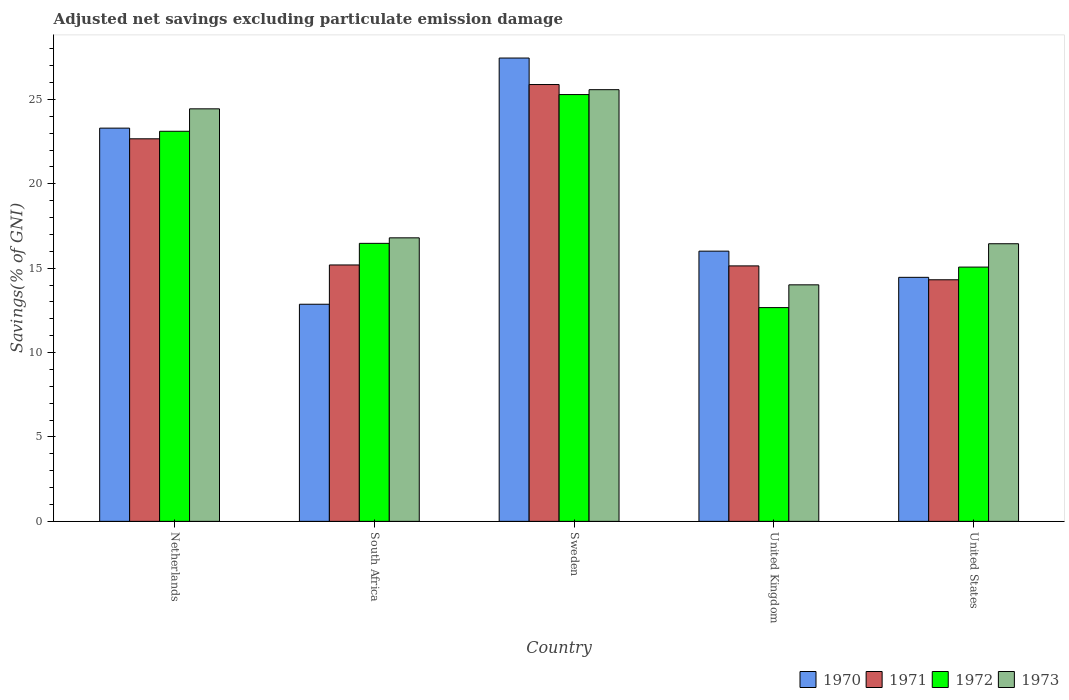How many different coloured bars are there?
Give a very brief answer. 4. Are the number of bars per tick equal to the number of legend labels?
Your response must be concise. Yes. How many bars are there on the 2nd tick from the left?
Offer a very short reply. 4. How many bars are there on the 3rd tick from the right?
Your response must be concise. 4. What is the label of the 2nd group of bars from the left?
Offer a terse response. South Africa. What is the adjusted net savings in 1970 in Sweden?
Give a very brief answer. 27.45. Across all countries, what is the maximum adjusted net savings in 1970?
Offer a very short reply. 27.45. Across all countries, what is the minimum adjusted net savings in 1971?
Your answer should be very brief. 14.31. What is the total adjusted net savings in 1972 in the graph?
Ensure brevity in your answer.  92.59. What is the difference between the adjusted net savings in 1973 in United Kingdom and that in United States?
Offer a terse response. -2.43. What is the difference between the adjusted net savings in 1972 in Sweden and the adjusted net savings in 1970 in South Africa?
Your answer should be very brief. 12.42. What is the average adjusted net savings in 1970 per country?
Your answer should be compact. 18.81. What is the difference between the adjusted net savings of/in 1970 and adjusted net savings of/in 1973 in United Kingdom?
Provide a succinct answer. 2. In how many countries, is the adjusted net savings in 1970 greater than 15 %?
Offer a very short reply. 3. What is the ratio of the adjusted net savings in 1970 in South Africa to that in United States?
Your response must be concise. 0.89. Is the difference between the adjusted net savings in 1970 in Netherlands and South Africa greater than the difference between the adjusted net savings in 1973 in Netherlands and South Africa?
Offer a very short reply. Yes. What is the difference between the highest and the second highest adjusted net savings in 1972?
Your answer should be compact. -8.81. What is the difference between the highest and the lowest adjusted net savings in 1973?
Your response must be concise. 11.56. Is the sum of the adjusted net savings in 1973 in South Africa and United Kingdom greater than the maximum adjusted net savings in 1972 across all countries?
Keep it short and to the point. Yes. What does the 3rd bar from the left in South Africa represents?
Give a very brief answer. 1972. Are all the bars in the graph horizontal?
Keep it short and to the point. No. Are the values on the major ticks of Y-axis written in scientific E-notation?
Make the answer very short. No. Does the graph contain any zero values?
Provide a short and direct response. No. What is the title of the graph?
Offer a terse response. Adjusted net savings excluding particulate emission damage. What is the label or title of the X-axis?
Ensure brevity in your answer.  Country. What is the label or title of the Y-axis?
Make the answer very short. Savings(% of GNI). What is the Savings(% of GNI) in 1970 in Netherlands?
Your answer should be compact. 23.3. What is the Savings(% of GNI) in 1971 in Netherlands?
Provide a short and direct response. 22.66. What is the Savings(% of GNI) in 1972 in Netherlands?
Offer a terse response. 23.11. What is the Savings(% of GNI) in 1973 in Netherlands?
Your answer should be compact. 24.44. What is the Savings(% of GNI) of 1970 in South Africa?
Offer a terse response. 12.86. What is the Savings(% of GNI) of 1971 in South Africa?
Offer a very short reply. 15.19. What is the Savings(% of GNI) of 1972 in South Africa?
Provide a short and direct response. 16.47. What is the Savings(% of GNI) of 1973 in South Africa?
Make the answer very short. 16.8. What is the Savings(% of GNI) in 1970 in Sweden?
Offer a very short reply. 27.45. What is the Savings(% of GNI) in 1971 in Sweden?
Your answer should be very brief. 25.88. What is the Savings(% of GNI) in 1972 in Sweden?
Provide a short and direct response. 25.28. What is the Savings(% of GNI) in 1973 in Sweden?
Your response must be concise. 25.57. What is the Savings(% of GNI) in 1970 in United Kingdom?
Ensure brevity in your answer.  16.01. What is the Savings(% of GNI) in 1971 in United Kingdom?
Keep it short and to the point. 15.13. What is the Savings(% of GNI) in 1972 in United Kingdom?
Your answer should be compact. 12.66. What is the Savings(% of GNI) of 1973 in United Kingdom?
Your answer should be very brief. 14.01. What is the Savings(% of GNI) in 1970 in United States?
Your answer should be compact. 14.46. What is the Savings(% of GNI) in 1971 in United States?
Provide a short and direct response. 14.31. What is the Savings(% of GNI) of 1972 in United States?
Make the answer very short. 15.06. What is the Savings(% of GNI) of 1973 in United States?
Make the answer very short. 16.45. Across all countries, what is the maximum Savings(% of GNI) of 1970?
Ensure brevity in your answer.  27.45. Across all countries, what is the maximum Savings(% of GNI) of 1971?
Offer a very short reply. 25.88. Across all countries, what is the maximum Savings(% of GNI) of 1972?
Make the answer very short. 25.28. Across all countries, what is the maximum Savings(% of GNI) of 1973?
Your answer should be compact. 25.57. Across all countries, what is the minimum Savings(% of GNI) of 1970?
Ensure brevity in your answer.  12.86. Across all countries, what is the minimum Savings(% of GNI) in 1971?
Ensure brevity in your answer.  14.31. Across all countries, what is the minimum Savings(% of GNI) in 1972?
Give a very brief answer. 12.66. Across all countries, what is the minimum Savings(% of GNI) of 1973?
Your answer should be very brief. 14.01. What is the total Savings(% of GNI) of 1970 in the graph?
Your answer should be compact. 94.07. What is the total Savings(% of GNI) of 1971 in the graph?
Keep it short and to the point. 93.18. What is the total Savings(% of GNI) in 1972 in the graph?
Provide a short and direct response. 92.59. What is the total Savings(% of GNI) in 1973 in the graph?
Your answer should be compact. 97.27. What is the difference between the Savings(% of GNI) of 1970 in Netherlands and that in South Africa?
Make the answer very short. 10.43. What is the difference between the Savings(% of GNI) in 1971 in Netherlands and that in South Africa?
Provide a succinct answer. 7.47. What is the difference between the Savings(% of GNI) in 1972 in Netherlands and that in South Africa?
Provide a short and direct response. 6.64. What is the difference between the Savings(% of GNI) in 1973 in Netherlands and that in South Africa?
Keep it short and to the point. 7.64. What is the difference between the Savings(% of GNI) in 1970 in Netherlands and that in Sweden?
Keep it short and to the point. -4.15. What is the difference between the Savings(% of GNI) of 1971 in Netherlands and that in Sweden?
Your answer should be very brief. -3.21. What is the difference between the Savings(% of GNI) of 1972 in Netherlands and that in Sweden?
Provide a succinct answer. -2.17. What is the difference between the Savings(% of GNI) in 1973 in Netherlands and that in Sweden?
Make the answer very short. -1.14. What is the difference between the Savings(% of GNI) in 1970 in Netherlands and that in United Kingdom?
Ensure brevity in your answer.  7.29. What is the difference between the Savings(% of GNI) in 1971 in Netherlands and that in United Kingdom?
Your response must be concise. 7.53. What is the difference between the Savings(% of GNI) in 1972 in Netherlands and that in United Kingdom?
Provide a short and direct response. 10.45. What is the difference between the Savings(% of GNI) of 1973 in Netherlands and that in United Kingdom?
Your answer should be very brief. 10.43. What is the difference between the Savings(% of GNI) in 1970 in Netherlands and that in United States?
Make the answer very short. 8.84. What is the difference between the Savings(% of GNI) of 1971 in Netherlands and that in United States?
Provide a short and direct response. 8.35. What is the difference between the Savings(% of GNI) in 1972 in Netherlands and that in United States?
Make the answer very short. 8.05. What is the difference between the Savings(% of GNI) in 1973 in Netherlands and that in United States?
Ensure brevity in your answer.  7.99. What is the difference between the Savings(% of GNI) of 1970 in South Africa and that in Sweden?
Keep it short and to the point. -14.59. What is the difference between the Savings(% of GNI) in 1971 in South Africa and that in Sweden?
Give a very brief answer. -10.69. What is the difference between the Savings(% of GNI) of 1972 in South Africa and that in Sweden?
Give a very brief answer. -8.81. What is the difference between the Savings(% of GNI) in 1973 in South Africa and that in Sweden?
Ensure brevity in your answer.  -8.78. What is the difference between the Savings(% of GNI) in 1970 in South Africa and that in United Kingdom?
Provide a succinct answer. -3.15. What is the difference between the Savings(% of GNI) in 1971 in South Africa and that in United Kingdom?
Provide a short and direct response. 0.06. What is the difference between the Savings(% of GNI) in 1972 in South Africa and that in United Kingdom?
Make the answer very short. 3.81. What is the difference between the Savings(% of GNI) in 1973 in South Africa and that in United Kingdom?
Your answer should be very brief. 2.78. What is the difference between the Savings(% of GNI) of 1970 in South Africa and that in United States?
Ensure brevity in your answer.  -1.59. What is the difference between the Savings(% of GNI) of 1971 in South Africa and that in United States?
Provide a short and direct response. 0.88. What is the difference between the Savings(% of GNI) of 1972 in South Africa and that in United States?
Your answer should be very brief. 1.41. What is the difference between the Savings(% of GNI) in 1973 in South Africa and that in United States?
Offer a very short reply. 0.35. What is the difference between the Savings(% of GNI) of 1970 in Sweden and that in United Kingdom?
Offer a very short reply. 11.44. What is the difference between the Savings(% of GNI) of 1971 in Sweden and that in United Kingdom?
Your response must be concise. 10.74. What is the difference between the Savings(% of GNI) in 1972 in Sweden and that in United Kingdom?
Give a very brief answer. 12.62. What is the difference between the Savings(% of GNI) of 1973 in Sweden and that in United Kingdom?
Offer a very short reply. 11.56. What is the difference between the Savings(% of GNI) in 1970 in Sweden and that in United States?
Provide a succinct answer. 12.99. What is the difference between the Savings(% of GNI) in 1971 in Sweden and that in United States?
Give a very brief answer. 11.57. What is the difference between the Savings(% of GNI) of 1972 in Sweden and that in United States?
Your response must be concise. 10.22. What is the difference between the Savings(% of GNI) in 1973 in Sweden and that in United States?
Your answer should be very brief. 9.13. What is the difference between the Savings(% of GNI) in 1970 in United Kingdom and that in United States?
Your answer should be very brief. 1.55. What is the difference between the Savings(% of GNI) of 1971 in United Kingdom and that in United States?
Your answer should be compact. 0.82. What is the difference between the Savings(% of GNI) in 1972 in United Kingdom and that in United States?
Offer a very short reply. -2.4. What is the difference between the Savings(% of GNI) of 1973 in United Kingdom and that in United States?
Your response must be concise. -2.43. What is the difference between the Savings(% of GNI) in 1970 in Netherlands and the Savings(% of GNI) in 1971 in South Africa?
Provide a succinct answer. 8.11. What is the difference between the Savings(% of GNI) of 1970 in Netherlands and the Savings(% of GNI) of 1972 in South Africa?
Your answer should be compact. 6.83. What is the difference between the Savings(% of GNI) in 1970 in Netherlands and the Savings(% of GNI) in 1973 in South Africa?
Offer a terse response. 6.5. What is the difference between the Savings(% of GNI) in 1971 in Netherlands and the Savings(% of GNI) in 1972 in South Africa?
Your answer should be very brief. 6.19. What is the difference between the Savings(% of GNI) in 1971 in Netherlands and the Savings(% of GNI) in 1973 in South Africa?
Make the answer very short. 5.87. What is the difference between the Savings(% of GNI) of 1972 in Netherlands and the Savings(% of GNI) of 1973 in South Africa?
Make the answer very short. 6.31. What is the difference between the Savings(% of GNI) of 1970 in Netherlands and the Savings(% of GNI) of 1971 in Sweden?
Your answer should be very brief. -2.58. What is the difference between the Savings(% of GNI) in 1970 in Netherlands and the Savings(% of GNI) in 1972 in Sweden?
Provide a short and direct response. -1.99. What is the difference between the Savings(% of GNI) of 1970 in Netherlands and the Savings(% of GNI) of 1973 in Sweden?
Your answer should be compact. -2.28. What is the difference between the Savings(% of GNI) of 1971 in Netherlands and the Savings(% of GNI) of 1972 in Sweden?
Your answer should be very brief. -2.62. What is the difference between the Savings(% of GNI) of 1971 in Netherlands and the Savings(% of GNI) of 1973 in Sweden?
Your answer should be compact. -2.91. What is the difference between the Savings(% of GNI) in 1972 in Netherlands and the Savings(% of GNI) in 1973 in Sweden?
Your answer should be very brief. -2.46. What is the difference between the Savings(% of GNI) in 1970 in Netherlands and the Savings(% of GNI) in 1971 in United Kingdom?
Give a very brief answer. 8.16. What is the difference between the Savings(% of GNI) in 1970 in Netherlands and the Savings(% of GNI) in 1972 in United Kingdom?
Offer a terse response. 10.63. What is the difference between the Savings(% of GNI) of 1970 in Netherlands and the Savings(% of GNI) of 1973 in United Kingdom?
Offer a very short reply. 9.28. What is the difference between the Savings(% of GNI) in 1971 in Netherlands and the Savings(% of GNI) in 1972 in United Kingdom?
Give a very brief answer. 10. What is the difference between the Savings(% of GNI) of 1971 in Netherlands and the Savings(% of GNI) of 1973 in United Kingdom?
Offer a very short reply. 8.65. What is the difference between the Savings(% of GNI) of 1972 in Netherlands and the Savings(% of GNI) of 1973 in United Kingdom?
Your response must be concise. 9.1. What is the difference between the Savings(% of GNI) in 1970 in Netherlands and the Savings(% of GNI) in 1971 in United States?
Your answer should be compact. 8.98. What is the difference between the Savings(% of GNI) of 1970 in Netherlands and the Savings(% of GNI) of 1972 in United States?
Keep it short and to the point. 8.23. What is the difference between the Savings(% of GNI) in 1970 in Netherlands and the Savings(% of GNI) in 1973 in United States?
Ensure brevity in your answer.  6.85. What is the difference between the Savings(% of GNI) in 1971 in Netherlands and the Savings(% of GNI) in 1972 in United States?
Keep it short and to the point. 7.6. What is the difference between the Savings(% of GNI) in 1971 in Netherlands and the Savings(% of GNI) in 1973 in United States?
Your answer should be very brief. 6.22. What is the difference between the Savings(% of GNI) of 1972 in Netherlands and the Savings(% of GNI) of 1973 in United States?
Your response must be concise. 6.66. What is the difference between the Savings(% of GNI) in 1970 in South Africa and the Savings(% of GNI) in 1971 in Sweden?
Ensure brevity in your answer.  -13.02. What is the difference between the Savings(% of GNI) of 1970 in South Africa and the Savings(% of GNI) of 1972 in Sweden?
Make the answer very short. -12.42. What is the difference between the Savings(% of GNI) of 1970 in South Africa and the Savings(% of GNI) of 1973 in Sweden?
Your response must be concise. -12.71. What is the difference between the Savings(% of GNI) in 1971 in South Africa and the Savings(% of GNI) in 1972 in Sweden?
Offer a terse response. -10.09. What is the difference between the Savings(% of GNI) of 1971 in South Africa and the Savings(% of GNI) of 1973 in Sweden?
Provide a short and direct response. -10.38. What is the difference between the Savings(% of GNI) of 1972 in South Africa and the Savings(% of GNI) of 1973 in Sweden?
Your response must be concise. -9.1. What is the difference between the Savings(% of GNI) in 1970 in South Africa and the Savings(% of GNI) in 1971 in United Kingdom?
Offer a very short reply. -2.27. What is the difference between the Savings(% of GNI) in 1970 in South Africa and the Savings(% of GNI) in 1972 in United Kingdom?
Your answer should be compact. 0.2. What is the difference between the Savings(% of GNI) in 1970 in South Africa and the Savings(% of GNI) in 1973 in United Kingdom?
Provide a short and direct response. -1.15. What is the difference between the Savings(% of GNI) in 1971 in South Africa and the Savings(% of GNI) in 1972 in United Kingdom?
Make the answer very short. 2.53. What is the difference between the Savings(% of GNI) in 1971 in South Africa and the Savings(% of GNI) in 1973 in United Kingdom?
Provide a succinct answer. 1.18. What is the difference between the Savings(% of GNI) in 1972 in South Africa and the Savings(% of GNI) in 1973 in United Kingdom?
Make the answer very short. 2.46. What is the difference between the Savings(% of GNI) in 1970 in South Africa and the Savings(% of GNI) in 1971 in United States?
Make the answer very short. -1.45. What is the difference between the Savings(% of GNI) in 1970 in South Africa and the Savings(% of GNI) in 1972 in United States?
Give a very brief answer. -2.2. What is the difference between the Savings(% of GNI) of 1970 in South Africa and the Savings(% of GNI) of 1973 in United States?
Keep it short and to the point. -3.58. What is the difference between the Savings(% of GNI) in 1971 in South Africa and the Savings(% of GNI) in 1972 in United States?
Offer a very short reply. 0.13. What is the difference between the Savings(% of GNI) of 1971 in South Africa and the Savings(% of GNI) of 1973 in United States?
Make the answer very short. -1.26. What is the difference between the Savings(% of GNI) of 1972 in South Africa and the Savings(% of GNI) of 1973 in United States?
Ensure brevity in your answer.  0.02. What is the difference between the Savings(% of GNI) of 1970 in Sweden and the Savings(% of GNI) of 1971 in United Kingdom?
Ensure brevity in your answer.  12.31. What is the difference between the Savings(% of GNI) of 1970 in Sweden and the Savings(% of GNI) of 1972 in United Kingdom?
Provide a succinct answer. 14.78. What is the difference between the Savings(% of GNI) in 1970 in Sweden and the Savings(% of GNI) in 1973 in United Kingdom?
Provide a short and direct response. 13.44. What is the difference between the Savings(% of GNI) in 1971 in Sweden and the Savings(% of GNI) in 1972 in United Kingdom?
Offer a very short reply. 13.21. What is the difference between the Savings(% of GNI) in 1971 in Sweden and the Savings(% of GNI) in 1973 in United Kingdom?
Ensure brevity in your answer.  11.87. What is the difference between the Savings(% of GNI) in 1972 in Sweden and the Savings(% of GNI) in 1973 in United Kingdom?
Make the answer very short. 11.27. What is the difference between the Savings(% of GNI) in 1970 in Sweden and the Savings(% of GNI) in 1971 in United States?
Your response must be concise. 13.14. What is the difference between the Savings(% of GNI) of 1970 in Sweden and the Savings(% of GNI) of 1972 in United States?
Offer a terse response. 12.38. What is the difference between the Savings(% of GNI) of 1970 in Sweden and the Savings(% of GNI) of 1973 in United States?
Give a very brief answer. 11. What is the difference between the Savings(% of GNI) of 1971 in Sweden and the Savings(% of GNI) of 1972 in United States?
Give a very brief answer. 10.81. What is the difference between the Savings(% of GNI) of 1971 in Sweden and the Savings(% of GNI) of 1973 in United States?
Your response must be concise. 9.43. What is the difference between the Savings(% of GNI) in 1972 in Sweden and the Savings(% of GNI) in 1973 in United States?
Provide a short and direct response. 8.84. What is the difference between the Savings(% of GNI) in 1970 in United Kingdom and the Savings(% of GNI) in 1971 in United States?
Provide a short and direct response. 1.7. What is the difference between the Savings(% of GNI) of 1970 in United Kingdom and the Savings(% of GNI) of 1972 in United States?
Make the answer very short. 0.94. What is the difference between the Savings(% of GNI) in 1970 in United Kingdom and the Savings(% of GNI) in 1973 in United States?
Keep it short and to the point. -0.44. What is the difference between the Savings(% of GNI) in 1971 in United Kingdom and the Savings(% of GNI) in 1972 in United States?
Your answer should be compact. 0.07. What is the difference between the Savings(% of GNI) in 1971 in United Kingdom and the Savings(% of GNI) in 1973 in United States?
Make the answer very short. -1.31. What is the difference between the Savings(% of GNI) in 1972 in United Kingdom and the Savings(% of GNI) in 1973 in United States?
Your answer should be very brief. -3.78. What is the average Savings(% of GNI) in 1970 per country?
Your answer should be compact. 18.81. What is the average Savings(% of GNI) in 1971 per country?
Provide a short and direct response. 18.64. What is the average Savings(% of GNI) of 1972 per country?
Give a very brief answer. 18.52. What is the average Savings(% of GNI) in 1973 per country?
Keep it short and to the point. 19.45. What is the difference between the Savings(% of GNI) in 1970 and Savings(% of GNI) in 1971 in Netherlands?
Provide a short and direct response. 0.63. What is the difference between the Savings(% of GNI) of 1970 and Savings(% of GNI) of 1972 in Netherlands?
Your response must be concise. 0.19. What is the difference between the Savings(% of GNI) of 1970 and Savings(% of GNI) of 1973 in Netherlands?
Offer a very short reply. -1.14. What is the difference between the Savings(% of GNI) of 1971 and Savings(% of GNI) of 1972 in Netherlands?
Offer a terse response. -0.45. What is the difference between the Savings(% of GNI) in 1971 and Savings(% of GNI) in 1973 in Netherlands?
Ensure brevity in your answer.  -1.77. What is the difference between the Savings(% of GNI) of 1972 and Savings(% of GNI) of 1973 in Netherlands?
Your answer should be compact. -1.33. What is the difference between the Savings(% of GNI) in 1970 and Savings(% of GNI) in 1971 in South Africa?
Provide a short and direct response. -2.33. What is the difference between the Savings(% of GNI) in 1970 and Savings(% of GNI) in 1972 in South Africa?
Offer a very short reply. -3.61. What is the difference between the Savings(% of GNI) of 1970 and Savings(% of GNI) of 1973 in South Africa?
Provide a succinct answer. -3.93. What is the difference between the Savings(% of GNI) of 1971 and Savings(% of GNI) of 1972 in South Africa?
Make the answer very short. -1.28. What is the difference between the Savings(% of GNI) in 1971 and Savings(% of GNI) in 1973 in South Africa?
Give a very brief answer. -1.61. What is the difference between the Savings(% of GNI) in 1972 and Savings(% of GNI) in 1973 in South Africa?
Give a very brief answer. -0.33. What is the difference between the Savings(% of GNI) in 1970 and Savings(% of GNI) in 1971 in Sweden?
Offer a very short reply. 1.57. What is the difference between the Savings(% of GNI) in 1970 and Savings(% of GNI) in 1972 in Sweden?
Your answer should be very brief. 2.16. What is the difference between the Savings(% of GNI) of 1970 and Savings(% of GNI) of 1973 in Sweden?
Offer a terse response. 1.87. What is the difference between the Savings(% of GNI) of 1971 and Savings(% of GNI) of 1972 in Sweden?
Provide a succinct answer. 0.59. What is the difference between the Savings(% of GNI) in 1971 and Savings(% of GNI) in 1973 in Sweden?
Provide a short and direct response. 0.3. What is the difference between the Savings(% of GNI) in 1972 and Savings(% of GNI) in 1973 in Sweden?
Provide a short and direct response. -0.29. What is the difference between the Savings(% of GNI) of 1970 and Savings(% of GNI) of 1971 in United Kingdom?
Offer a terse response. 0.87. What is the difference between the Savings(% of GNI) of 1970 and Savings(% of GNI) of 1972 in United Kingdom?
Provide a short and direct response. 3.34. What is the difference between the Savings(% of GNI) in 1970 and Savings(% of GNI) in 1973 in United Kingdom?
Provide a succinct answer. 2. What is the difference between the Savings(% of GNI) in 1971 and Savings(% of GNI) in 1972 in United Kingdom?
Ensure brevity in your answer.  2.47. What is the difference between the Savings(% of GNI) in 1971 and Savings(% of GNI) in 1973 in United Kingdom?
Ensure brevity in your answer.  1.12. What is the difference between the Savings(% of GNI) in 1972 and Savings(% of GNI) in 1973 in United Kingdom?
Keep it short and to the point. -1.35. What is the difference between the Savings(% of GNI) in 1970 and Savings(% of GNI) in 1971 in United States?
Keep it short and to the point. 0.14. What is the difference between the Savings(% of GNI) of 1970 and Savings(% of GNI) of 1972 in United States?
Provide a short and direct response. -0.61. What is the difference between the Savings(% of GNI) in 1970 and Savings(% of GNI) in 1973 in United States?
Your answer should be compact. -1.99. What is the difference between the Savings(% of GNI) in 1971 and Savings(% of GNI) in 1972 in United States?
Provide a succinct answer. -0.75. What is the difference between the Savings(% of GNI) in 1971 and Savings(% of GNI) in 1973 in United States?
Make the answer very short. -2.13. What is the difference between the Savings(% of GNI) of 1972 and Savings(% of GNI) of 1973 in United States?
Offer a very short reply. -1.38. What is the ratio of the Savings(% of GNI) in 1970 in Netherlands to that in South Africa?
Make the answer very short. 1.81. What is the ratio of the Savings(% of GNI) in 1971 in Netherlands to that in South Africa?
Offer a terse response. 1.49. What is the ratio of the Savings(% of GNI) in 1972 in Netherlands to that in South Africa?
Your answer should be compact. 1.4. What is the ratio of the Savings(% of GNI) of 1973 in Netherlands to that in South Africa?
Keep it short and to the point. 1.46. What is the ratio of the Savings(% of GNI) of 1970 in Netherlands to that in Sweden?
Ensure brevity in your answer.  0.85. What is the ratio of the Savings(% of GNI) of 1971 in Netherlands to that in Sweden?
Make the answer very short. 0.88. What is the ratio of the Savings(% of GNI) in 1972 in Netherlands to that in Sweden?
Ensure brevity in your answer.  0.91. What is the ratio of the Savings(% of GNI) of 1973 in Netherlands to that in Sweden?
Keep it short and to the point. 0.96. What is the ratio of the Savings(% of GNI) in 1970 in Netherlands to that in United Kingdom?
Offer a terse response. 1.46. What is the ratio of the Savings(% of GNI) in 1971 in Netherlands to that in United Kingdom?
Your response must be concise. 1.5. What is the ratio of the Savings(% of GNI) in 1972 in Netherlands to that in United Kingdom?
Keep it short and to the point. 1.82. What is the ratio of the Savings(% of GNI) of 1973 in Netherlands to that in United Kingdom?
Offer a very short reply. 1.74. What is the ratio of the Savings(% of GNI) of 1970 in Netherlands to that in United States?
Ensure brevity in your answer.  1.61. What is the ratio of the Savings(% of GNI) of 1971 in Netherlands to that in United States?
Ensure brevity in your answer.  1.58. What is the ratio of the Savings(% of GNI) of 1972 in Netherlands to that in United States?
Ensure brevity in your answer.  1.53. What is the ratio of the Savings(% of GNI) in 1973 in Netherlands to that in United States?
Ensure brevity in your answer.  1.49. What is the ratio of the Savings(% of GNI) in 1970 in South Africa to that in Sweden?
Offer a terse response. 0.47. What is the ratio of the Savings(% of GNI) of 1971 in South Africa to that in Sweden?
Provide a short and direct response. 0.59. What is the ratio of the Savings(% of GNI) in 1972 in South Africa to that in Sweden?
Your response must be concise. 0.65. What is the ratio of the Savings(% of GNI) of 1973 in South Africa to that in Sweden?
Your answer should be very brief. 0.66. What is the ratio of the Savings(% of GNI) in 1970 in South Africa to that in United Kingdom?
Provide a succinct answer. 0.8. What is the ratio of the Savings(% of GNI) in 1971 in South Africa to that in United Kingdom?
Provide a succinct answer. 1. What is the ratio of the Savings(% of GNI) of 1972 in South Africa to that in United Kingdom?
Keep it short and to the point. 1.3. What is the ratio of the Savings(% of GNI) in 1973 in South Africa to that in United Kingdom?
Give a very brief answer. 1.2. What is the ratio of the Savings(% of GNI) of 1970 in South Africa to that in United States?
Your response must be concise. 0.89. What is the ratio of the Savings(% of GNI) of 1971 in South Africa to that in United States?
Provide a succinct answer. 1.06. What is the ratio of the Savings(% of GNI) of 1972 in South Africa to that in United States?
Offer a very short reply. 1.09. What is the ratio of the Savings(% of GNI) of 1973 in South Africa to that in United States?
Offer a terse response. 1.02. What is the ratio of the Savings(% of GNI) of 1970 in Sweden to that in United Kingdom?
Provide a short and direct response. 1.71. What is the ratio of the Savings(% of GNI) in 1971 in Sweden to that in United Kingdom?
Offer a very short reply. 1.71. What is the ratio of the Savings(% of GNI) of 1972 in Sweden to that in United Kingdom?
Provide a short and direct response. 2. What is the ratio of the Savings(% of GNI) in 1973 in Sweden to that in United Kingdom?
Your answer should be very brief. 1.83. What is the ratio of the Savings(% of GNI) in 1970 in Sweden to that in United States?
Provide a succinct answer. 1.9. What is the ratio of the Savings(% of GNI) of 1971 in Sweden to that in United States?
Offer a very short reply. 1.81. What is the ratio of the Savings(% of GNI) of 1972 in Sweden to that in United States?
Your answer should be very brief. 1.68. What is the ratio of the Savings(% of GNI) of 1973 in Sweden to that in United States?
Make the answer very short. 1.55. What is the ratio of the Savings(% of GNI) of 1970 in United Kingdom to that in United States?
Make the answer very short. 1.11. What is the ratio of the Savings(% of GNI) in 1971 in United Kingdom to that in United States?
Make the answer very short. 1.06. What is the ratio of the Savings(% of GNI) of 1972 in United Kingdom to that in United States?
Give a very brief answer. 0.84. What is the ratio of the Savings(% of GNI) in 1973 in United Kingdom to that in United States?
Keep it short and to the point. 0.85. What is the difference between the highest and the second highest Savings(% of GNI) of 1970?
Keep it short and to the point. 4.15. What is the difference between the highest and the second highest Savings(% of GNI) in 1971?
Your response must be concise. 3.21. What is the difference between the highest and the second highest Savings(% of GNI) in 1972?
Ensure brevity in your answer.  2.17. What is the difference between the highest and the second highest Savings(% of GNI) in 1973?
Your answer should be compact. 1.14. What is the difference between the highest and the lowest Savings(% of GNI) of 1970?
Ensure brevity in your answer.  14.59. What is the difference between the highest and the lowest Savings(% of GNI) of 1971?
Give a very brief answer. 11.57. What is the difference between the highest and the lowest Savings(% of GNI) of 1972?
Your response must be concise. 12.62. What is the difference between the highest and the lowest Savings(% of GNI) in 1973?
Make the answer very short. 11.56. 